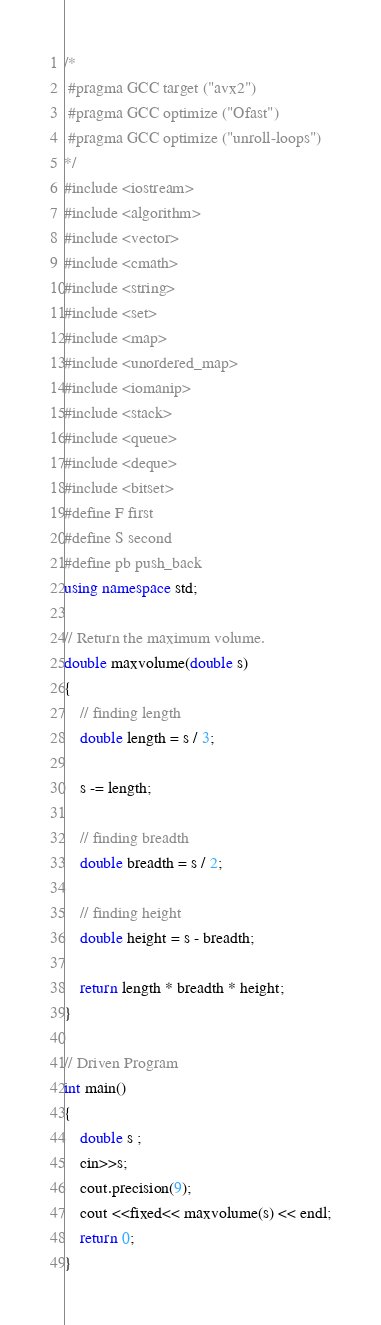Convert code to text. <code><loc_0><loc_0><loc_500><loc_500><_C++_>/*
 #pragma GCC target ("avx2")
 #pragma GCC optimize ("Ofast")
 #pragma GCC optimize ("unroll-loops")
*/
#include <iostream>
#include <algorithm>
#include <vector>
#include <cmath>
#include <string>
#include <set>
#include <map>
#include <unordered_map>
#include <iomanip>
#include <stack>
#include <queue>
#include <deque>
#include <bitset>
#define F first
#define S second
#define pb push_back
using namespace std;
  
// Return the maximum volume.
double maxvolume(double s)
{
    // finding length
    double length = s / 3;
  
    s -= length;
  
    // finding breadth
    double breadth = s / 2;
  
    // finding height
    double height = s - breadth;
  
    return length * breadth * height;
}
  
// Driven Program
int main()
{
    double s ;
    cin>>s;
    cout.precision(9);
    cout <<fixed<< maxvolume(s) << endl;
    return 0;
}
</code> 